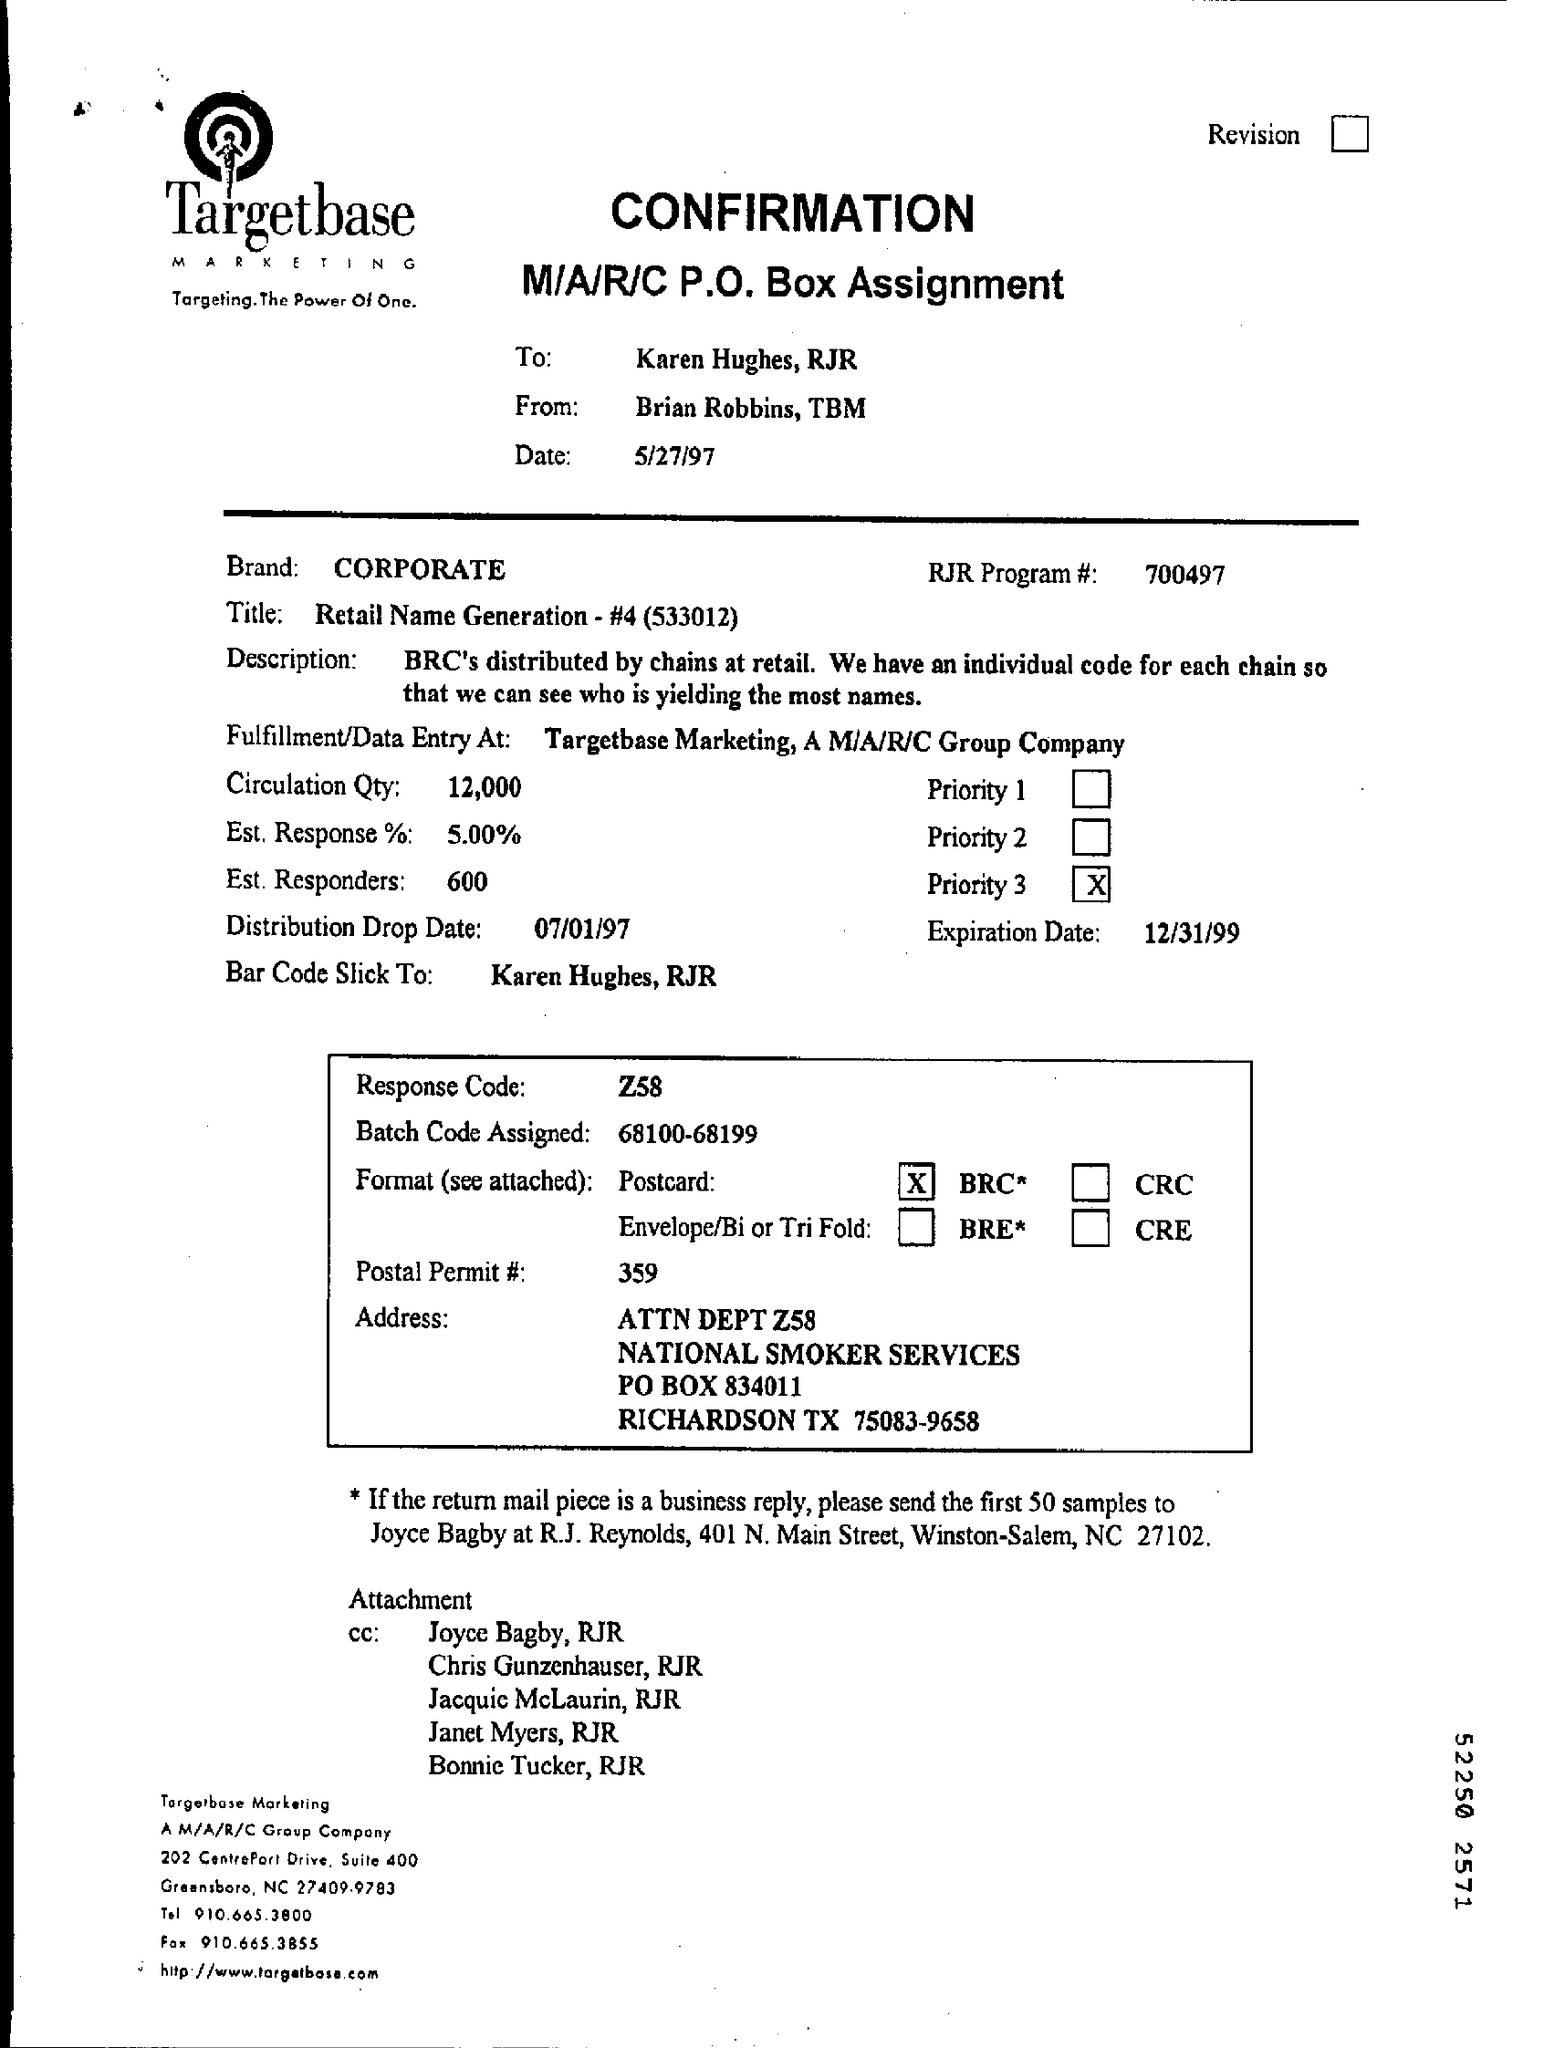What is the response code ?
Provide a succinct answer. Z58. What is the post permit number?
Make the answer very short. 359. What is the est response % ?
Offer a terse response. 5.00%. What is the circulation qty ?
Your answer should be very brief. 12,000. 